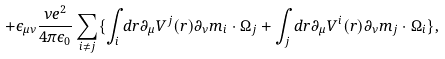<formula> <loc_0><loc_0><loc_500><loc_500>+ \epsilon _ { \mu \nu } \frac { \nu e ^ { 2 } } { 4 \pi \epsilon _ { 0 } } \sum _ { i \neq j } \{ \int _ { i } d { r } \partial _ { \mu } V ^ { j } ( { r } ) \partial _ { \nu } { m } _ { i } \cdot \Omega _ { j } + \int _ { j } d { r } \partial _ { \mu } V ^ { i } ( { r } ) \partial _ { \nu } { m } _ { j } \cdot \Omega _ { i } \} ,</formula> 